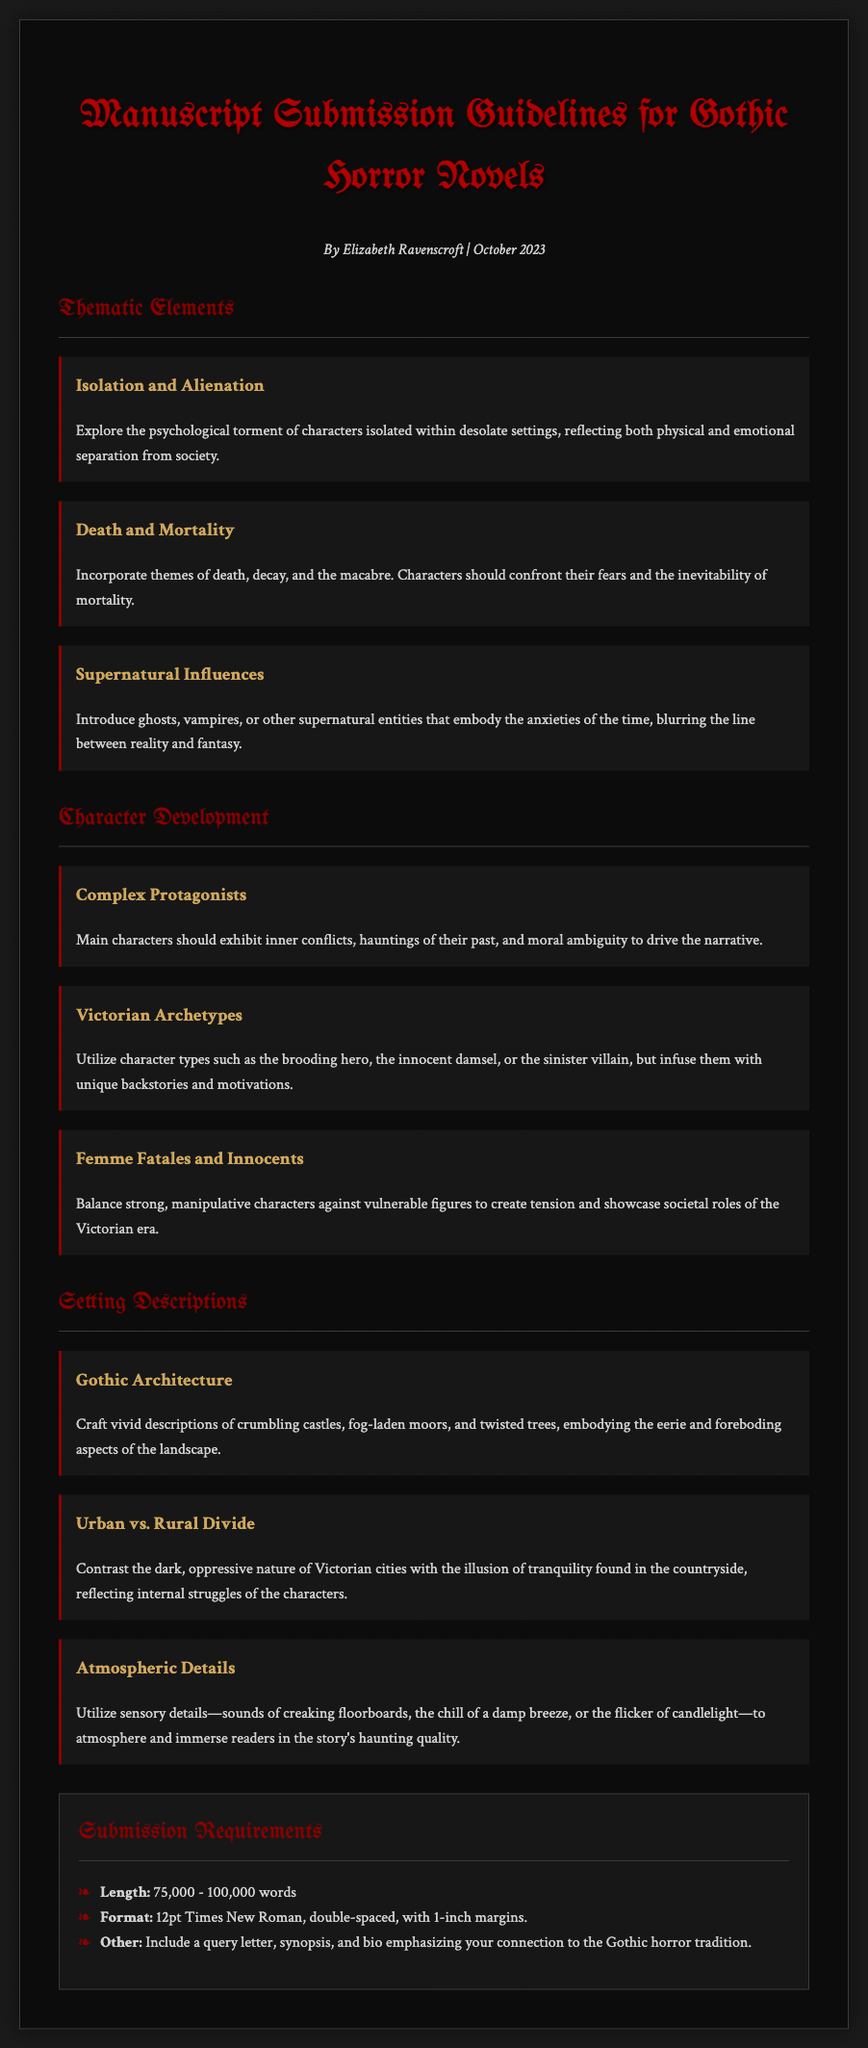What is the title of the document? The title is explicitly stated at the top of the document as the subject of the content.
Answer: Manuscript Submission Guidelines for Gothic Horror Novels Who is the author of the document? The author's name is presented in the author-date section, providing authorship information.
Answer: Elizabeth Ravenscroft What is the submission word count range? The word count is listed in the submission requirements section, highlighting the expectations for manuscript length.
Answer: 75,000 - 100,000 words What theme involves characters dealing with the inevitability of death? The theme is labeled in the thematic elements section, focusing on a significant aspect of Gothic horror.
Answer: Death and Mortality Which character type is described as a strong, manipulative figure? This character type is detailed in the character development section, providing a clear categorization within Gothic narratives.
Answer: Femme Fatales What architectural style should be vividly described in the settings? The architectural style is specified in the setting descriptions section, marking a hallmark of Gothic literature.
Answer: Gothic Architecture What atmospheric detail is suggested to immerse readers? The document points out a specific sensory detail to enhance the reader's experience of the narrative.
Answer: Sounds of creaking floorboards How should the manuscript be formatted? The formatting requirements are clearly outlined to ensure submissions adhere to a certain standard.
Answer: 12pt Times New Roman, double-spaced, with 1-inch margins What is the required content to include alongside the manuscript? The document lists essential components that must accompany the submission, ensuring completeness.
Answer: A query letter, synopsis, and bio 